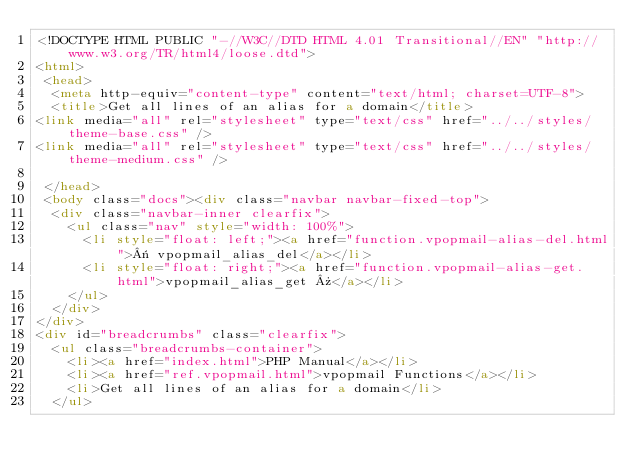Convert code to text. <code><loc_0><loc_0><loc_500><loc_500><_HTML_><!DOCTYPE HTML PUBLIC "-//W3C//DTD HTML 4.01 Transitional//EN" "http://www.w3.org/TR/html4/loose.dtd">
<html>
 <head>
  <meta http-equiv="content-type" content="text/html; charset=UTF-8">
  <title>Get all lines of an alias for a domain</title>
<link media="all" rel="stylesheet" type="text/css" href="../../styles/theme-base.css" />
<link media="all" rel="stylesheet" type="text/css" href="../../styles/theme-medium.css" />

 </head>
 <body class="docs"><div class="navbar navbar-fixed-top">
  <div class="navbar-inner clearfix">
    <ul class="nav" style="width: 100%">
      <li style="float: left;"><a href="function.vpopmail-alias-del.html">« vpopmail_alias_del</a></li>
      <li style="float: right;"><a href="function.vpopmail-alias-get.html">vpopmail_alias_get »</a></li>
    </ul>
  </div>
</div>
<div id="breadcrumbs" class="clearfix">
  <ul class="breadcrumbs-container">
    <li><a href="index.html">PHP Manual</a></li>
    <li><a href="ref.vpopmail.html">vpopmail Functions</a></li>
    <li>Get all lines of an alias for a domain</li>
  </ul></code> 